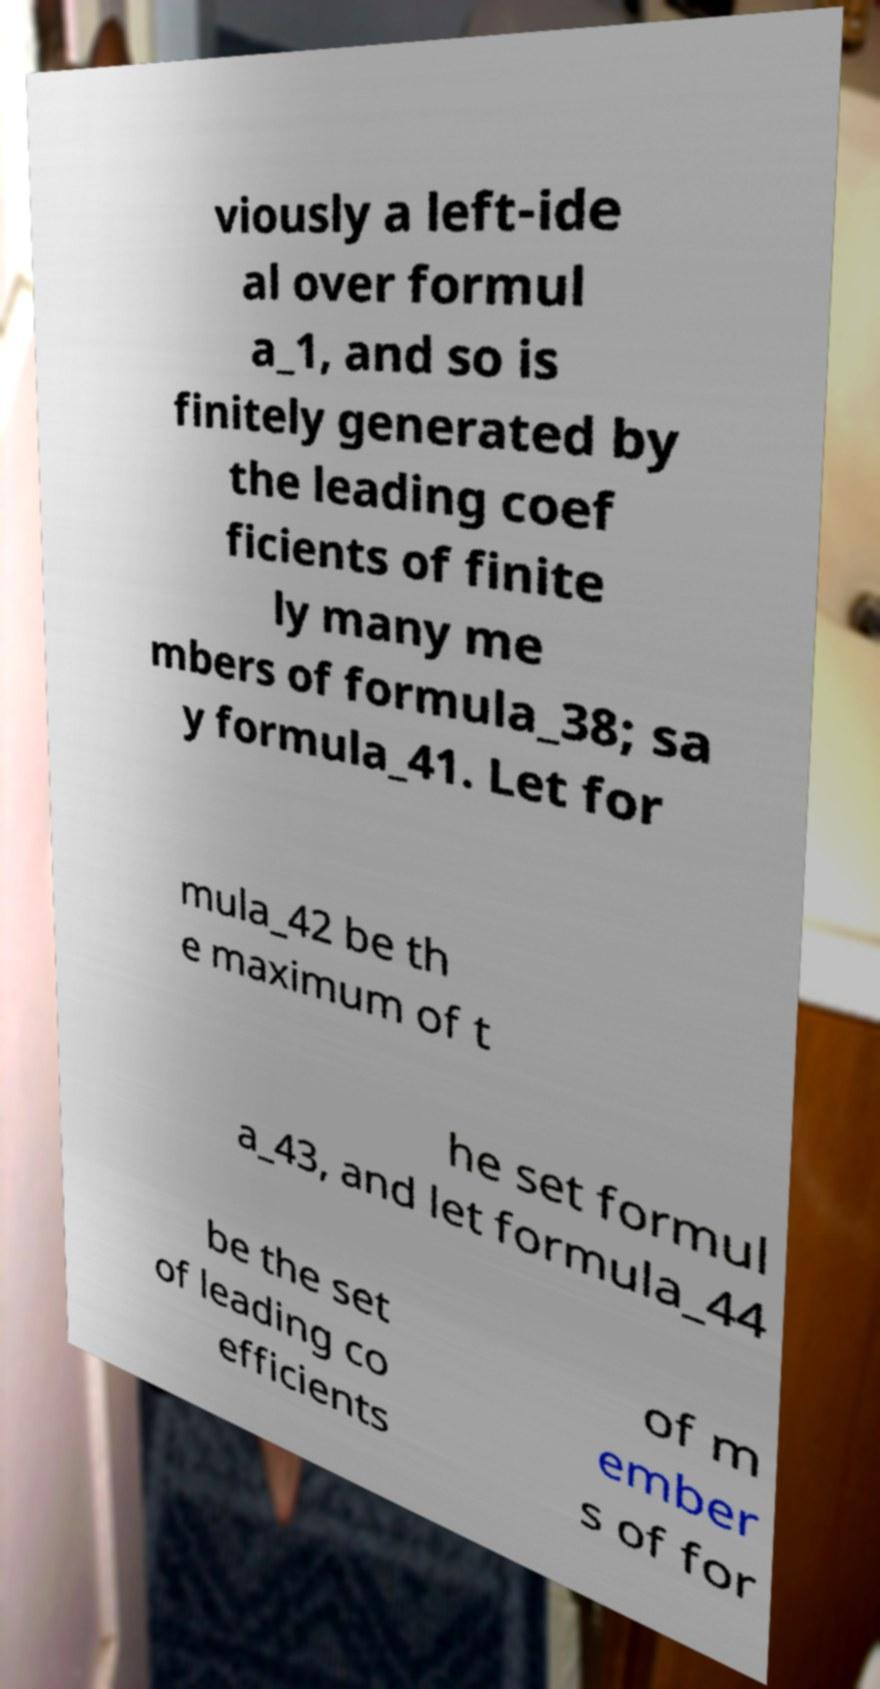Can you accurately transcribe the text from the provided image for me? viously a left-ide al over formul a_1, and so is finitely generated by the leading coef ficients of finite ly many me mbers of formula_38; sa y formula_41. Let for mula_42 be th e maximum of t he set formul a_43, and let formula_44 be the set of leading co efficients of m ember s of for 